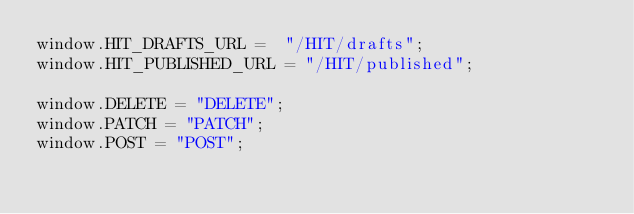Convert code to text. <code><loc_0><loc_0><loc_500><loc_500><_JavaScript_>window.HIT_DRAFTS_URL =  "/HIT/drafts";
window.HIT_PUBLISHED_URL = "/HIT/published";

window.DELETE = "DELETE";
window.PATCH = "PATCH";
window.POST = "POST";
</code> 